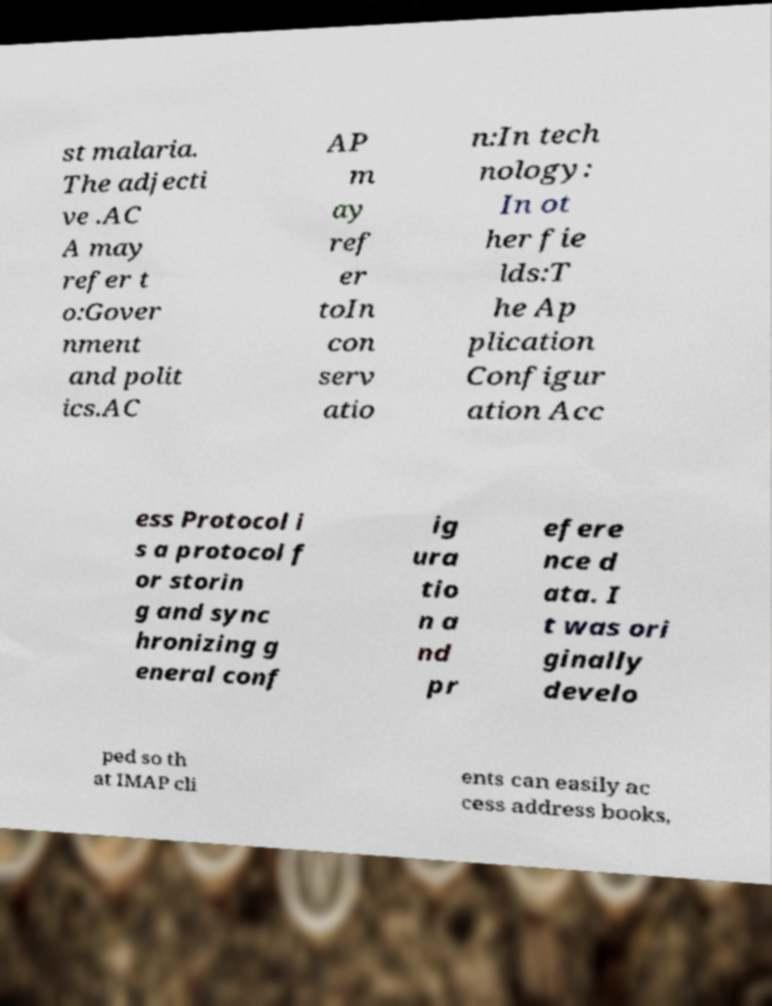There's text embedded in this image that I need extracted. Can you transcribe it verbatim? st malaria. The adjecti ve .AC A may refer t o:Gover nment and polit ics.AC AP m ay ref er toIn con serv atio n:In tech nology: In ot her fie lds:T he Ap plication Configur ation Acc ess Protocol i s a protocol f or storin g and sync hronizing g eneral conf ig ura tio n a nd pr efere nce d ata. I t was ori ginally develo ped so th at IMAP cli ents can easily ac cess address books, 